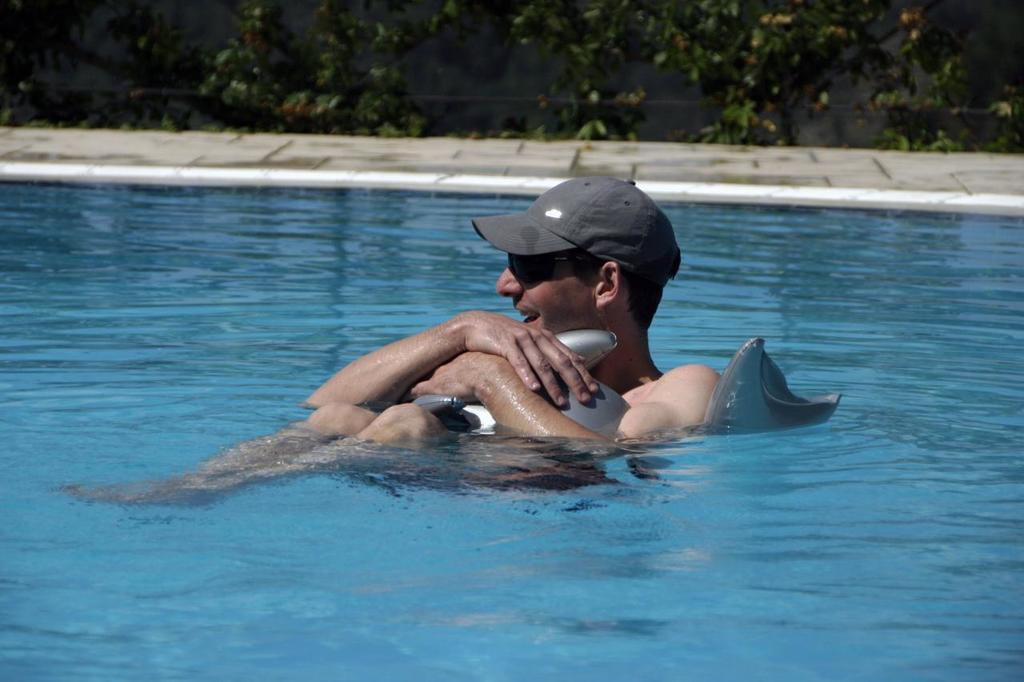What is the man in the image wearing on his head? The man is wearing a cap in the image. What is the man wearing to protect his eyes? The man is wearing goggles in the image. What is the man holding in the image? The man is holding an inflatable tube in the image. Where is the man located in the image? The man is in the water in the image. What can be seen behind the man in the image? There is a path and trees behind the man in the image. How does the man pump air into the inflatable tube in the image? There is no indication in the image that the man is pumping air into the inflatable tube. What type of fly can be seen buzzing around the man's head in the image? There are no flies present in the image. 